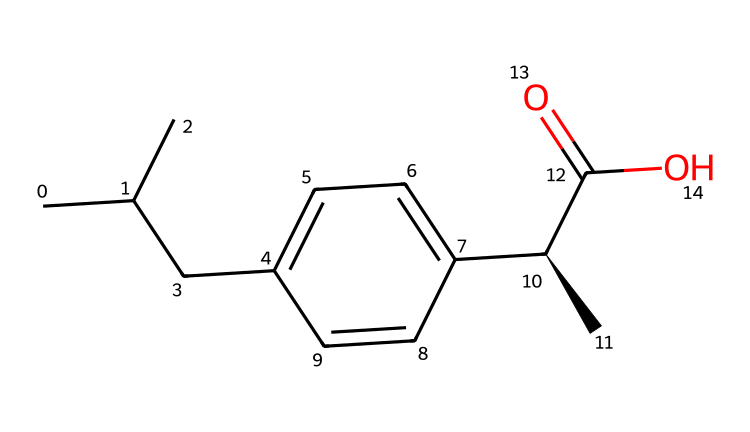how many carbon atoms are in ibuprofen? By examining the SMILES representation, we can count the number of carbon (C) symbols present. There are 13 carbon atoms in the structure.
Answer: 13 what is the functional group present in ibuprofen? In the provided SMILES, the notation "C(=O)O" indicates the presence of a carboxylic acid functional group as it features a carbon atom double-bonded to an oxygen atom and single-bonded to a hydroxyl group (-OH).
Answer: carboxylic acid how many double bonds are in ibuprofen? By analyzing the SMILES representation, there is 1 double bond present between the carbon atom and the oxygen atom in the carboxylic acid group (C(=O)). Other bonds in the structure are single bonds.
Answer: 1 is ibuprofen a hypervalent compound? Ibuprofen does not have a central atom that exceeds the octet rule typically seen in hypervalent compounds, as it does not contain a central atom with more than eight electrons.
Answer: no what is the stereochemistry of the chiral center in ibuprofen? The notation "[C@H]" in the SMILES indicates that there is a chiral carbon atom with specific configuration. This denotes an S or R configuration, but further analysis might be needed to determine which is present. The presence of an asymmetric carbon suggests chirality in the structure.
Answer: chiral how many total hydrogen atoms are connected to carbon atoms in ibuprofen? In the structure, every carbon atom typically forms four bonds. By deducing the number of hydrogen atoms based on the carbon's bonding environment and the overall structure, it is determined that there are 18 hydrogen atoms connected to carbon atoms.
Answer: 18 